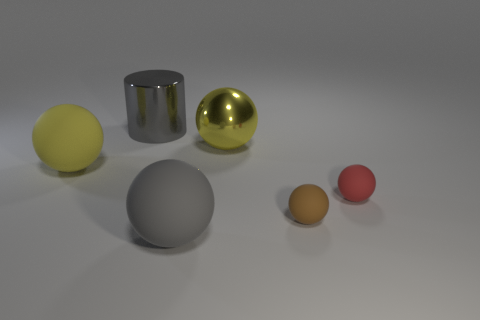Can you describe the lighting and shadows in the scene? Certainly, the scene is illuminated by a soft, diffuse light source coming from the top left, as evidenced by the gentle shadows cast to the lower right of the objects. These shadows are soft-edged, indicating that the light source is not extremely close. There's also a subtle reflection on the surfaces of the reflective objects, suggesting additional ambient light in the environment that adds to the overall softness and depth of the scene. 